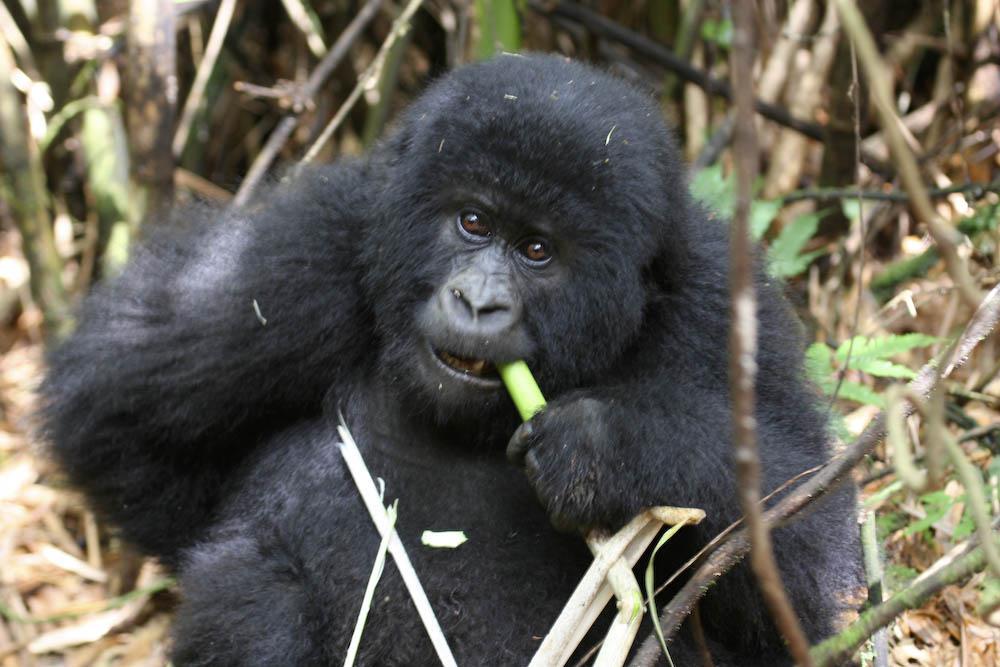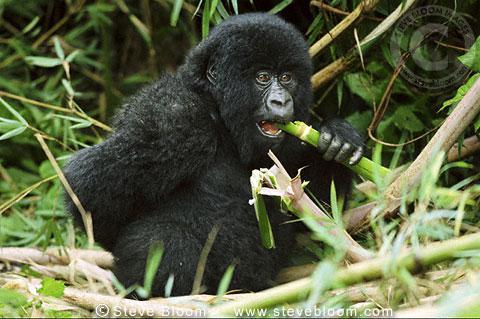The first image is the image on the left, the second image is the image on the right. Evaluate the accuracy of this statement regarding the images: "In each image there is a single gorilla and it is eating.". Is it true? Answer yes or no. Yes. The first image is the image on the left, the second image is the image on the right. Evaluate the accuracy of this statement regarding the images: "One image shows a gorilla holding some type of stalk by its face, and the other image features an adult gorilla moving toward the camera.". Is it true? Answer yes or no. No. 